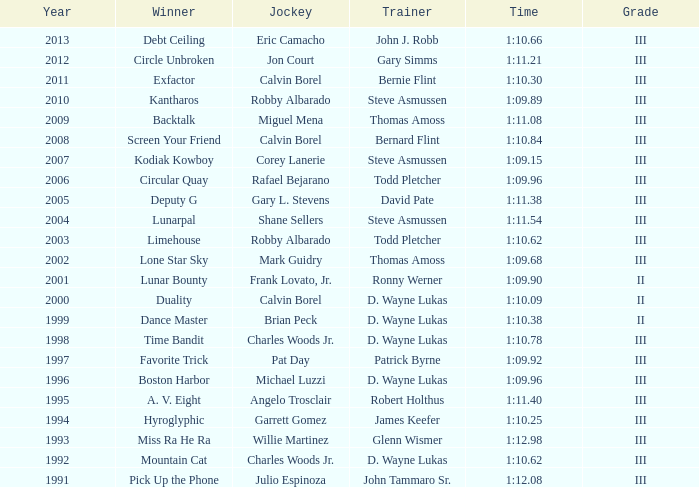Which coach achieved a time of 1:10.09 in a year prior to 2009? D. Wayne Lukas. 